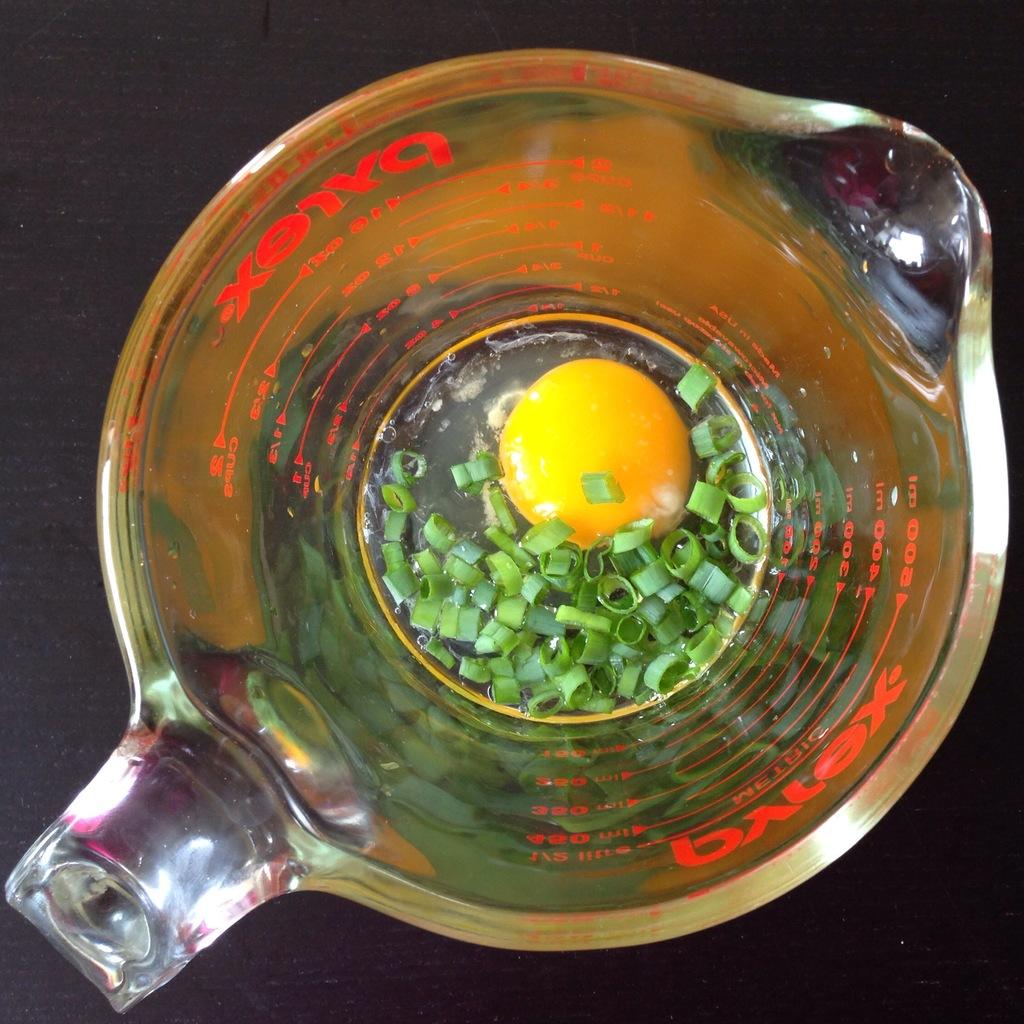What brand of measuring cup is this?
Keep it short and to the point. Pyrex. How many cups is the top line?
Provide a short and direct response. 2. 